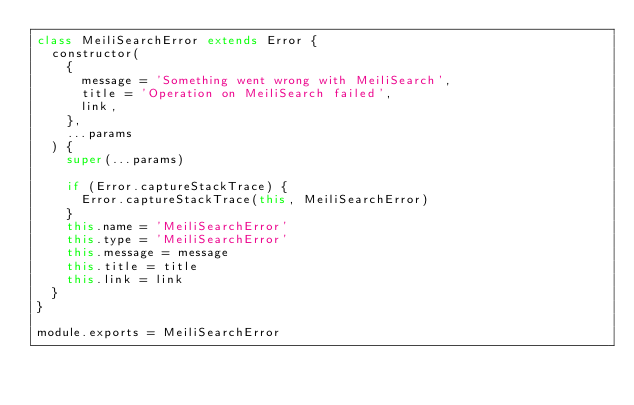<code> <loc_0><loc_0><loc_500><loc_500><_JavaScript_>class MeiliSearchError extends Error {
  constructor(
    {
      message = 'Something went wrong with MeiliSearch',
      title = 'Operation on MeiliSearch failed',
      link,
    },
    ...params
  ) {
    super(...params)

    if (Error.captureStackTrace) {
      Error.captureStackTrace(this, MeiliSearchError)
    }
    this.name = 'MeiliSearchError'
    this.type = 'MeiliSearchError'
    this.message = message
    this.title = title
    this.link = link
  }
}

module.exports = MeiliSearchError
</code> 